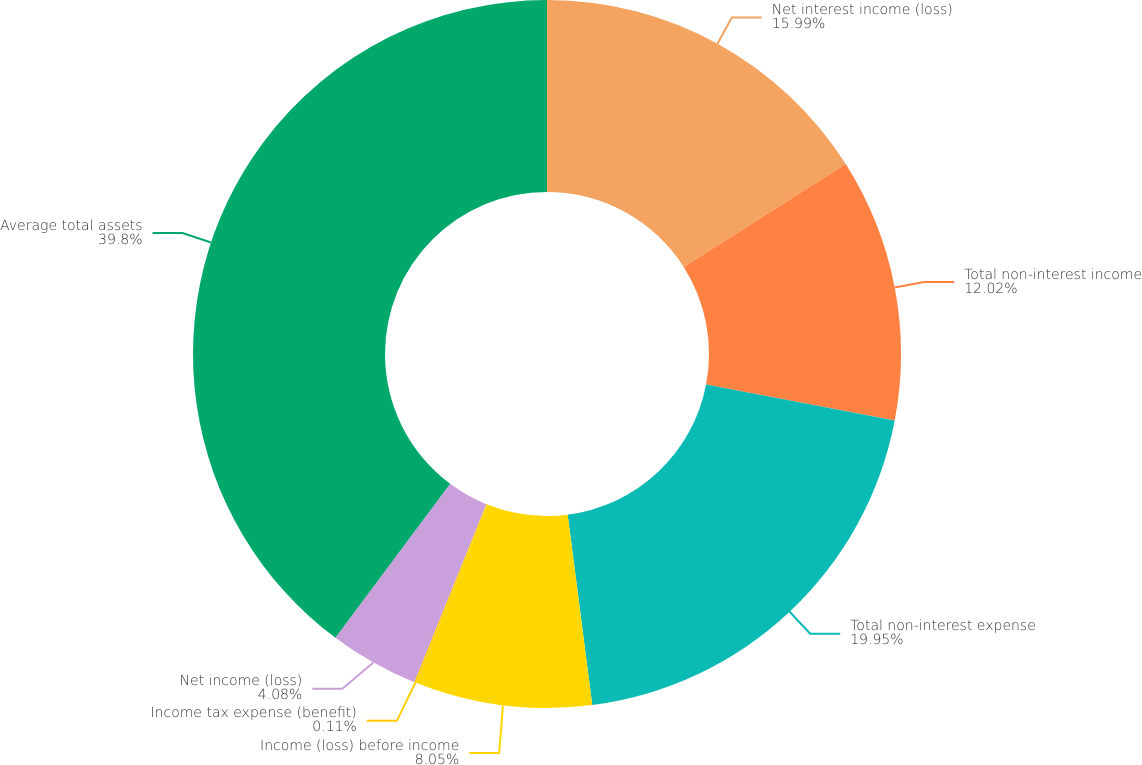Convert chart to OTSL. <chart><loc_0><loc_0><loc_500><loc_500><pie_chart><fcel>Net interest income (loss)<fcel>Total non-interest income<fcel>Total non-interest expense<fcel>Income (loss) before income<fcel>Income tax expense (benefit)<fcel>Net income (loss)<fcel>Average total assets<nl><fcel>15.99%<fcel>12.02%<fcel>19.96%<fcel>8.05%<fcel>0.11%<fcel>4.08%<fcel>39.81%<nl></chart> 